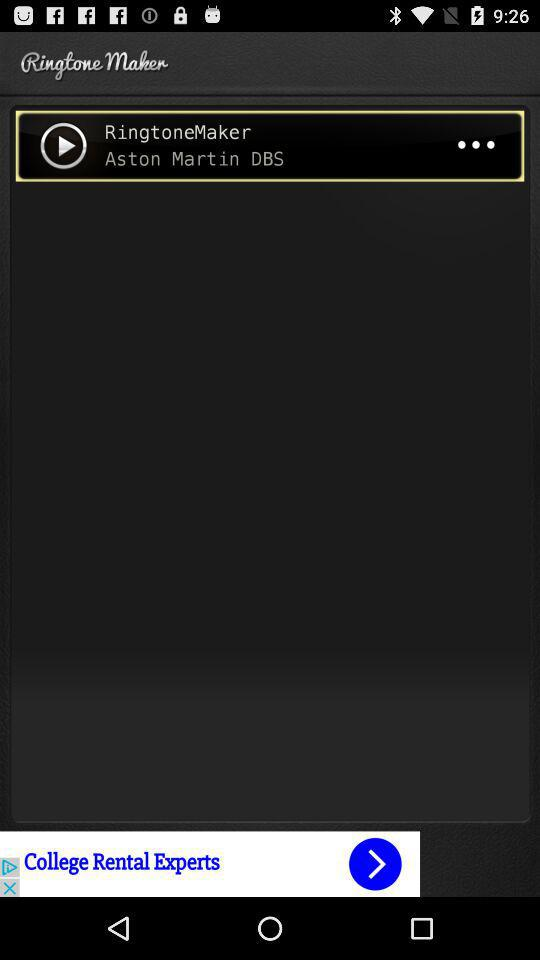What is the name of the application? The name of the application is "RingtoneMaker". 